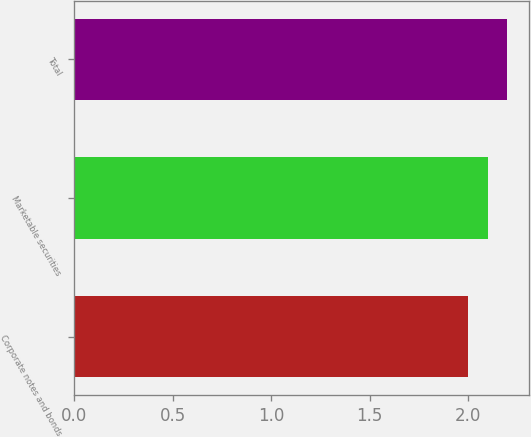Convert chart to OTSL. <chart><loc_0><loc_0><loc_500><loc_500><bar_chart><fcel>Corporate notes and bonds<fcel>Marketable securities<fcel>Total<nl><fcel>2<fcel>2.1<fcel>2.2<nl></chart> 